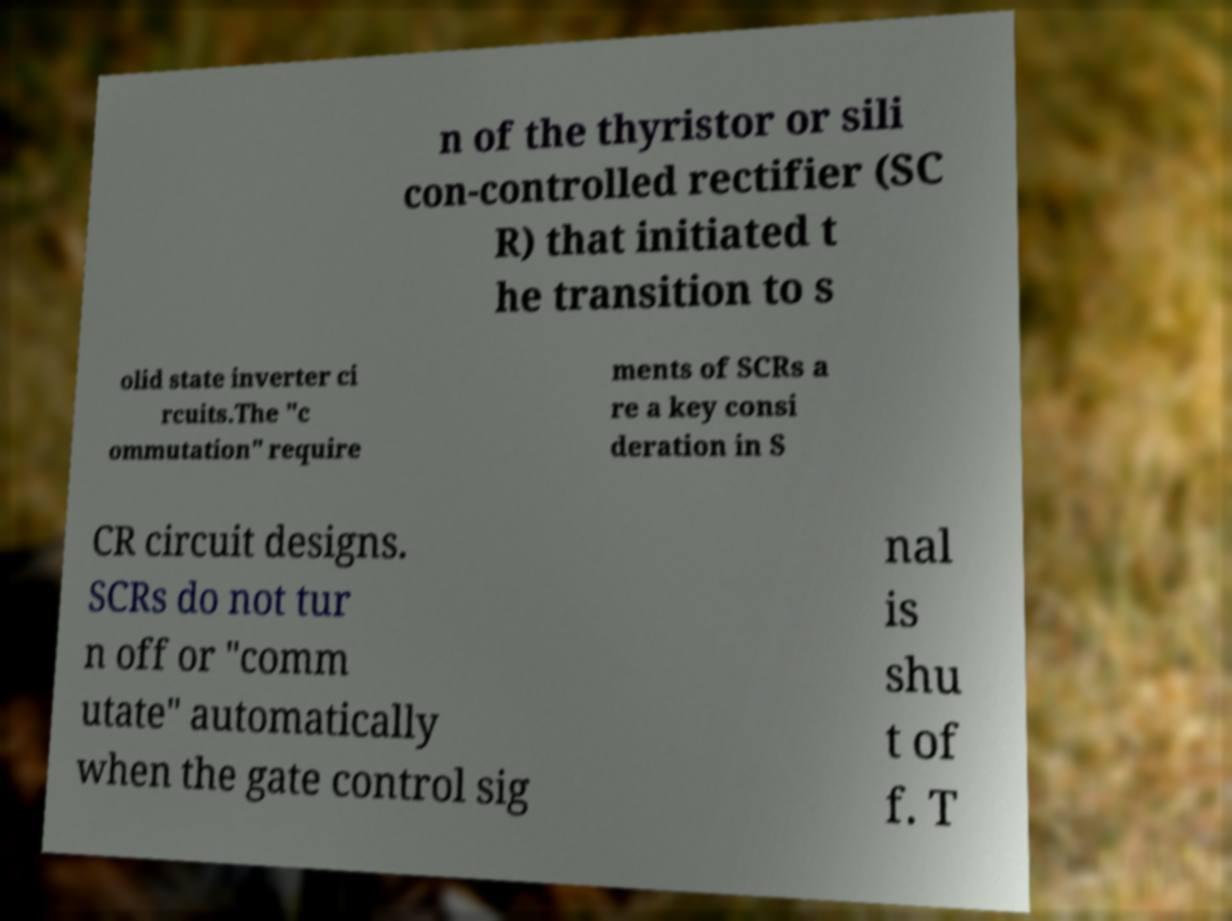For documentation purposes, I need the text within this image transcribed. Could you provide that? n of the thyristor or sili con-controlled rectifier (SC R) that initiated t he transition to s olid state inverter ci rcuits.The "c ommutation" require ments of SCRs a re a key consi deration in S CR circuit designs. SCRs do not tur n off or "comm utate" automatically when the gate control sig nal is shu t of f. T 